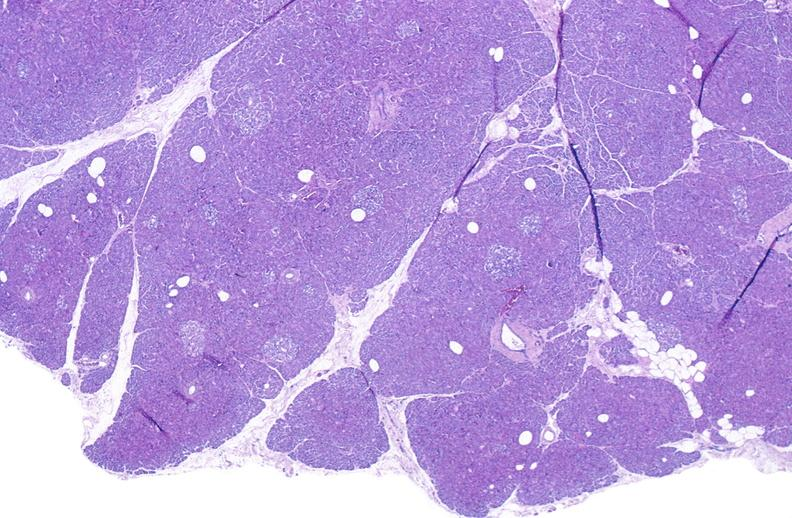what does this image show?
Answer the question using a single word or phrase. Normal pancreas 